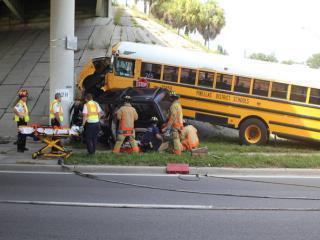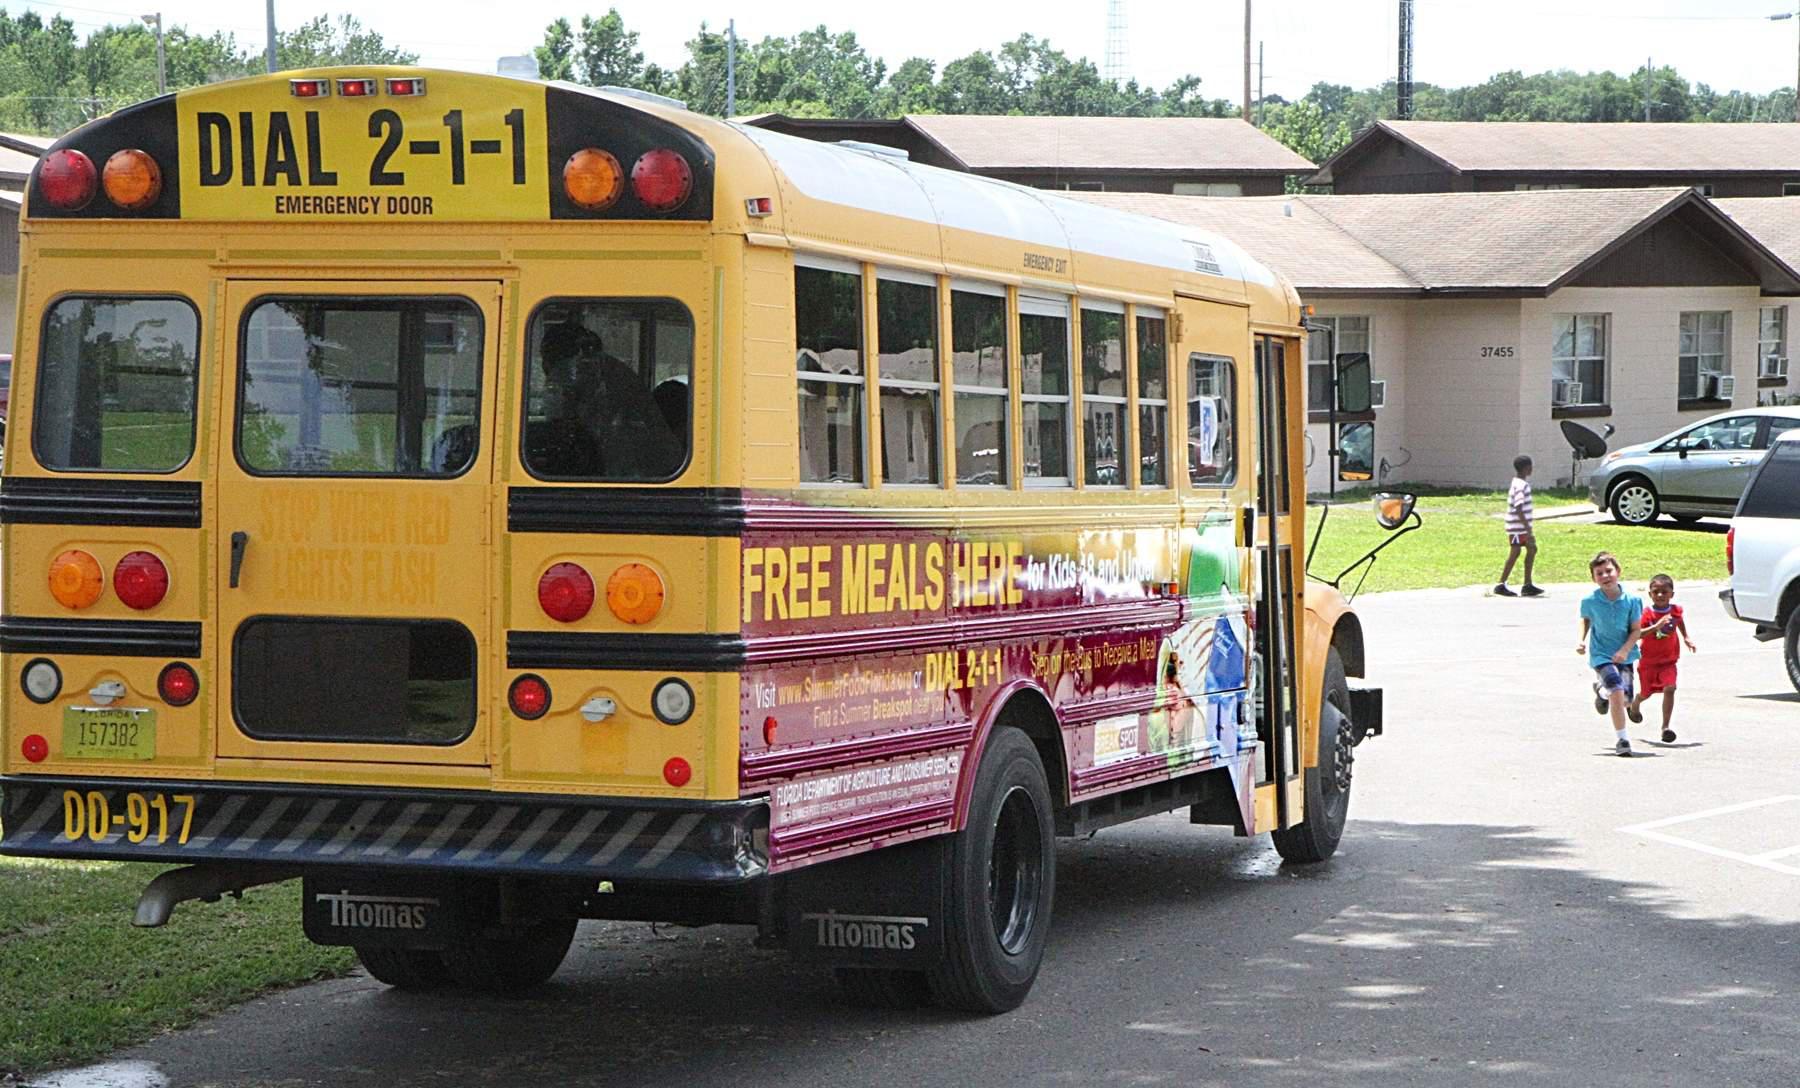The first image is the image on the left, the second image is the image on the right. Examine the images to the left and right. Is the description "At least one bus is driving next to other cars." accurate? Answer yes or no. No. The first image is the image on the left, the second image is the image on the right. Considering the images on both sides, is "One image shows at least five school buses parked next to each other." valid? Answer yes or no. No. 